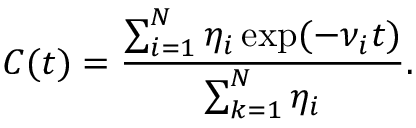<formula> <loc_0><loc_0><loc_500><loc_500>C ( t ) = \frac { \sum _ { i = 1 } ^ { N } \eta _ { i } \exp ( - \nu _ { i } t ) } { \sum _ { k = 1 } ^ { N } \eta _ { i } } .</formula> 